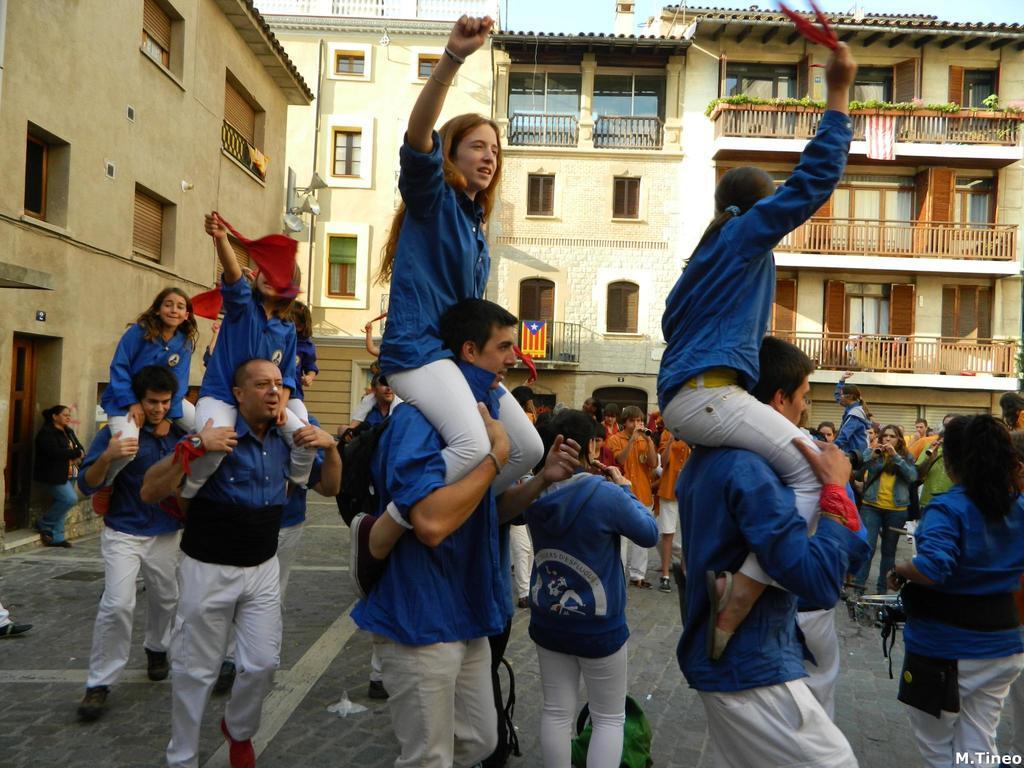In one or two sentences, can you explain what this image depicts? In this image we can see many buildings, there are windows, there is a curtain, there is a balcony, there is a door, there are group of people standing on the ground, there is sky at the top. 